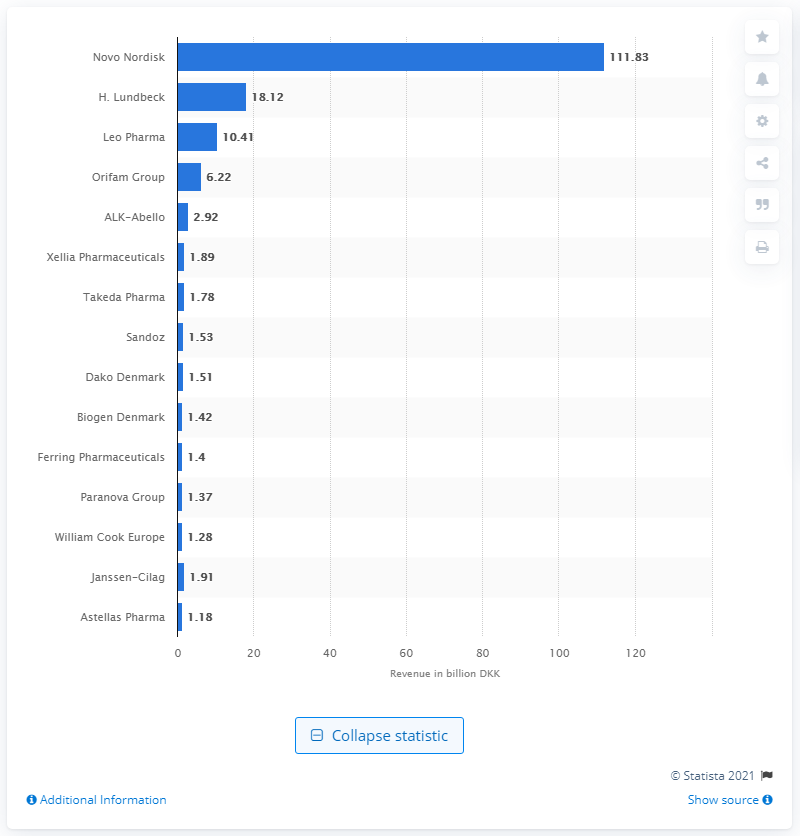List a handful of essential elements in this visual. Novo Nordisk was the Danish pharmaceutical company that earned the highest revenues in 2018. 